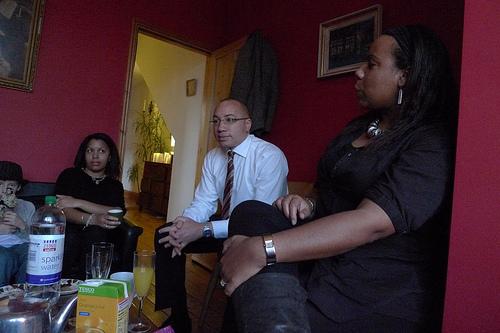What is this person doing?
Be succinct. Sitting. How many people are wearing glasses?
Concise answer only. 1. Is someone pouring wine?
Answer briefly. No. Are the people sad in the photo?
Answer briefly. No. What kind of establishment was this picture taken?
Write a very short answer. House. What room is he in?
Give a very brief answer. Living room. What ethnic group does the male belong to?
Keep it brief. Black. Is there a man in this photo?
Keep it brief. Yes. Is the bamboo plant in the next room live?
Answer briefly. Yes. What color are the walls?
Quick response, please. Red. Is this woman married to the guy on the right?
Be succinct. No. Is the man probably in a restaurant or at home?
Keep it brief. Home. 